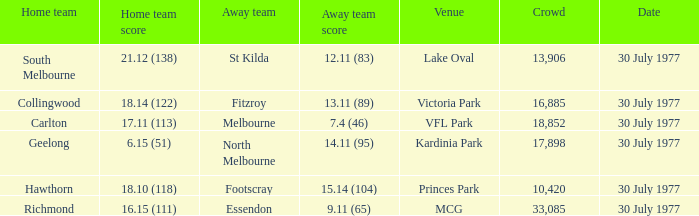Whom is the home team when the away team score is 9.11 (65)? Richmond. 